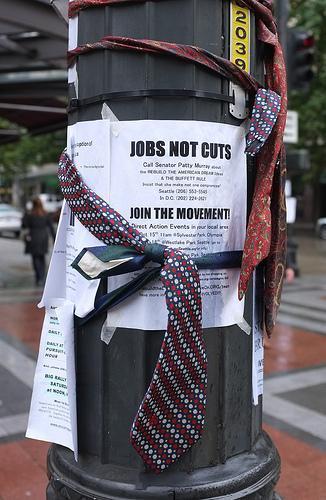How many poles are in the picture?
Give a very brief answer. 1. 